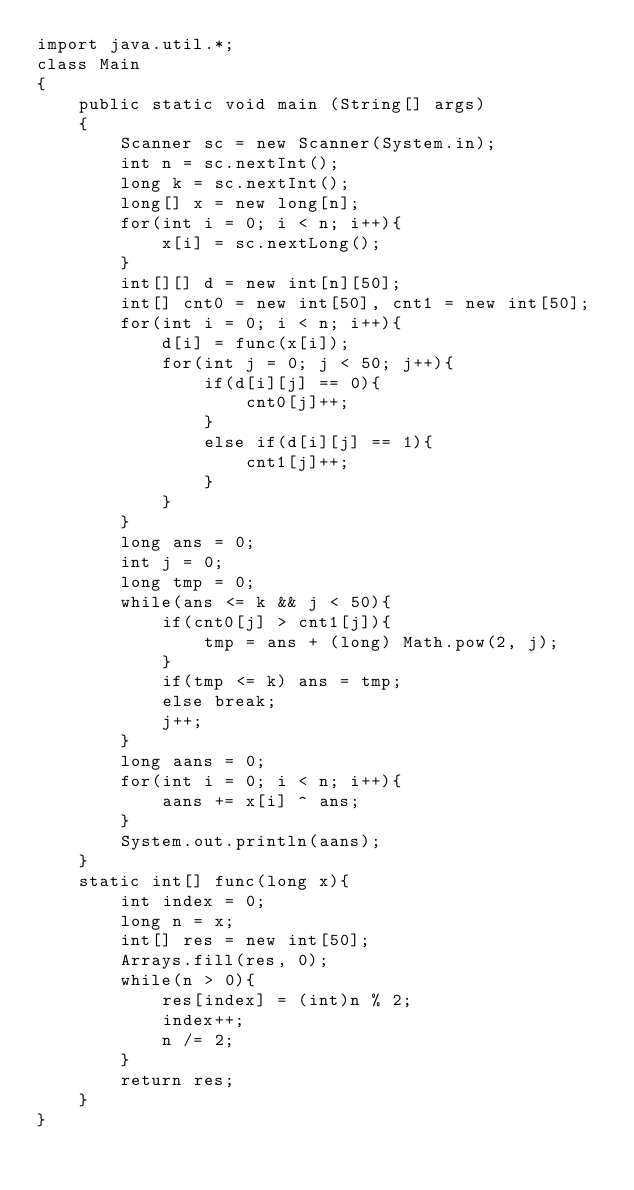Convert code to text. <code><loc_0><loc_0><loc_500><loc_500><_Java_>import java.util.*;
class Main
{
    public static void main (String[] args)
    {
        Scanner sc = new Scanner(System.in);
        int n = sc.nextInt();
        long k = sc.nextInt();
        long[] x = new long[n];
        for(int i = 0; i < n; i++){
            x[i] = sc.nextLong();
        }
        int[][] d = new int[n][50];
        int[] cnt0 = new int[50], cnt1 = new int[50];
        for(int i = 0; i < n; i++){
            d[i] = func(x[i]);
            for(int j = 0; j < 50; j++){
                if(d[i][j] == 0){
                    cnt0[j]++;
                }
                else if(d[i][j] == 1){
                    cnt1[j]++;
                }
            }
        }
        long ans = 0;
        int j = 0;
        long tmp = 0;
        while(ans <= k && j < 50){
            if(cnt0[j] > cnt1[j]){
                tmp = ans + (long) Math.pow(2, j);
            }
            if(tmp <= k) ans = tmp;
            else break;
            j++;
        }
        long aans = 0;
        for(int i = 0; i < n; i++){
            aans += x[i] ^ ans;
        }
        System.out.println(aans);
    }
    static int[] func(long x){
        int index = 0;
        long n = x;
        int[] res = new int[50];
        Arrays.fill(res, 0);
        while(n > 0){
            res[index] = (int)n % 2;
            index++;
            n /= 2;
        }
        return res;
    }
}</code> 